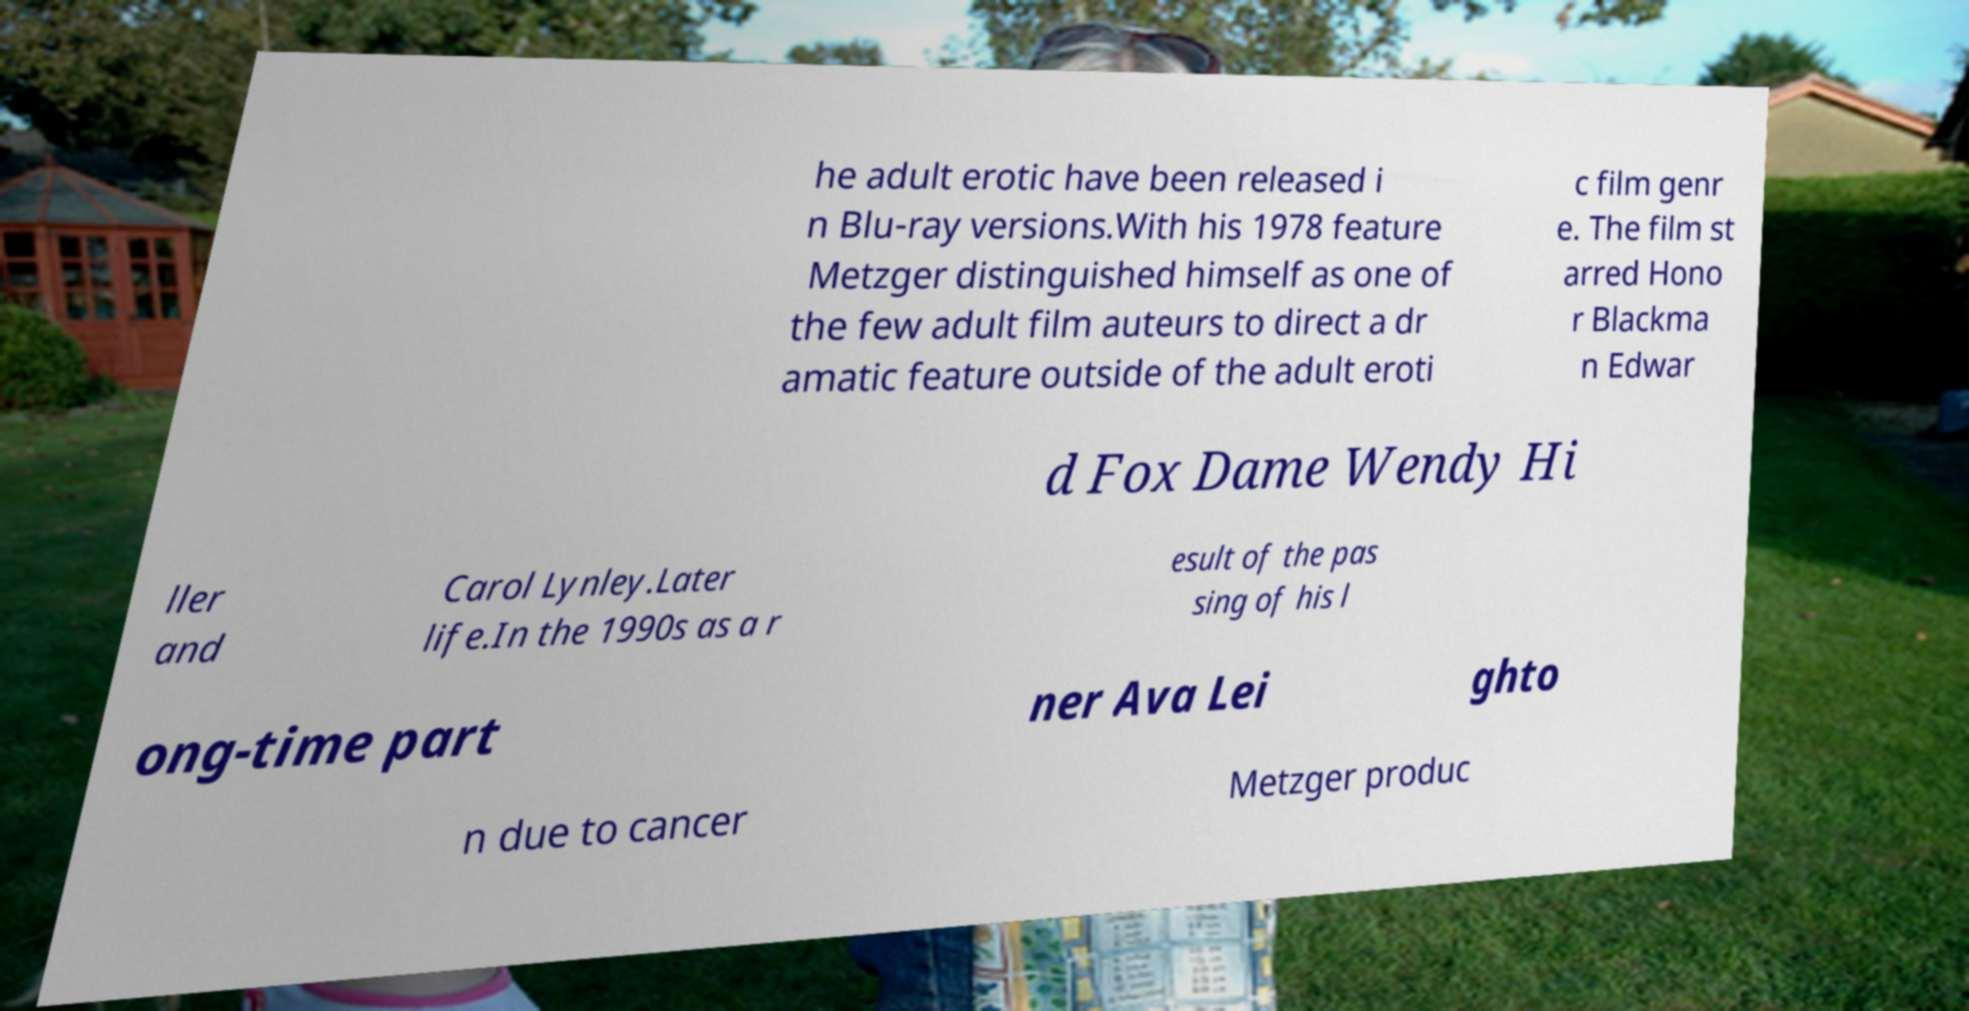Please identify and transcribe the text found in this image. he adult erotic have been released i n Blu-ray versions.With his 1978 feature Metzger distinguished himself as one of the few adult film auteurs to direct a dr amatic feature outside of the adult eroti c film genr e. The film st arred Hono r Blackma n Edwar d Fox Dame Wendy Hi ller and Carol Lynley.Later life.In the 1990s as a r esult of the pas sing of his l ong-time part ner Ava Lei ghto n due to cancer Metzger produc 